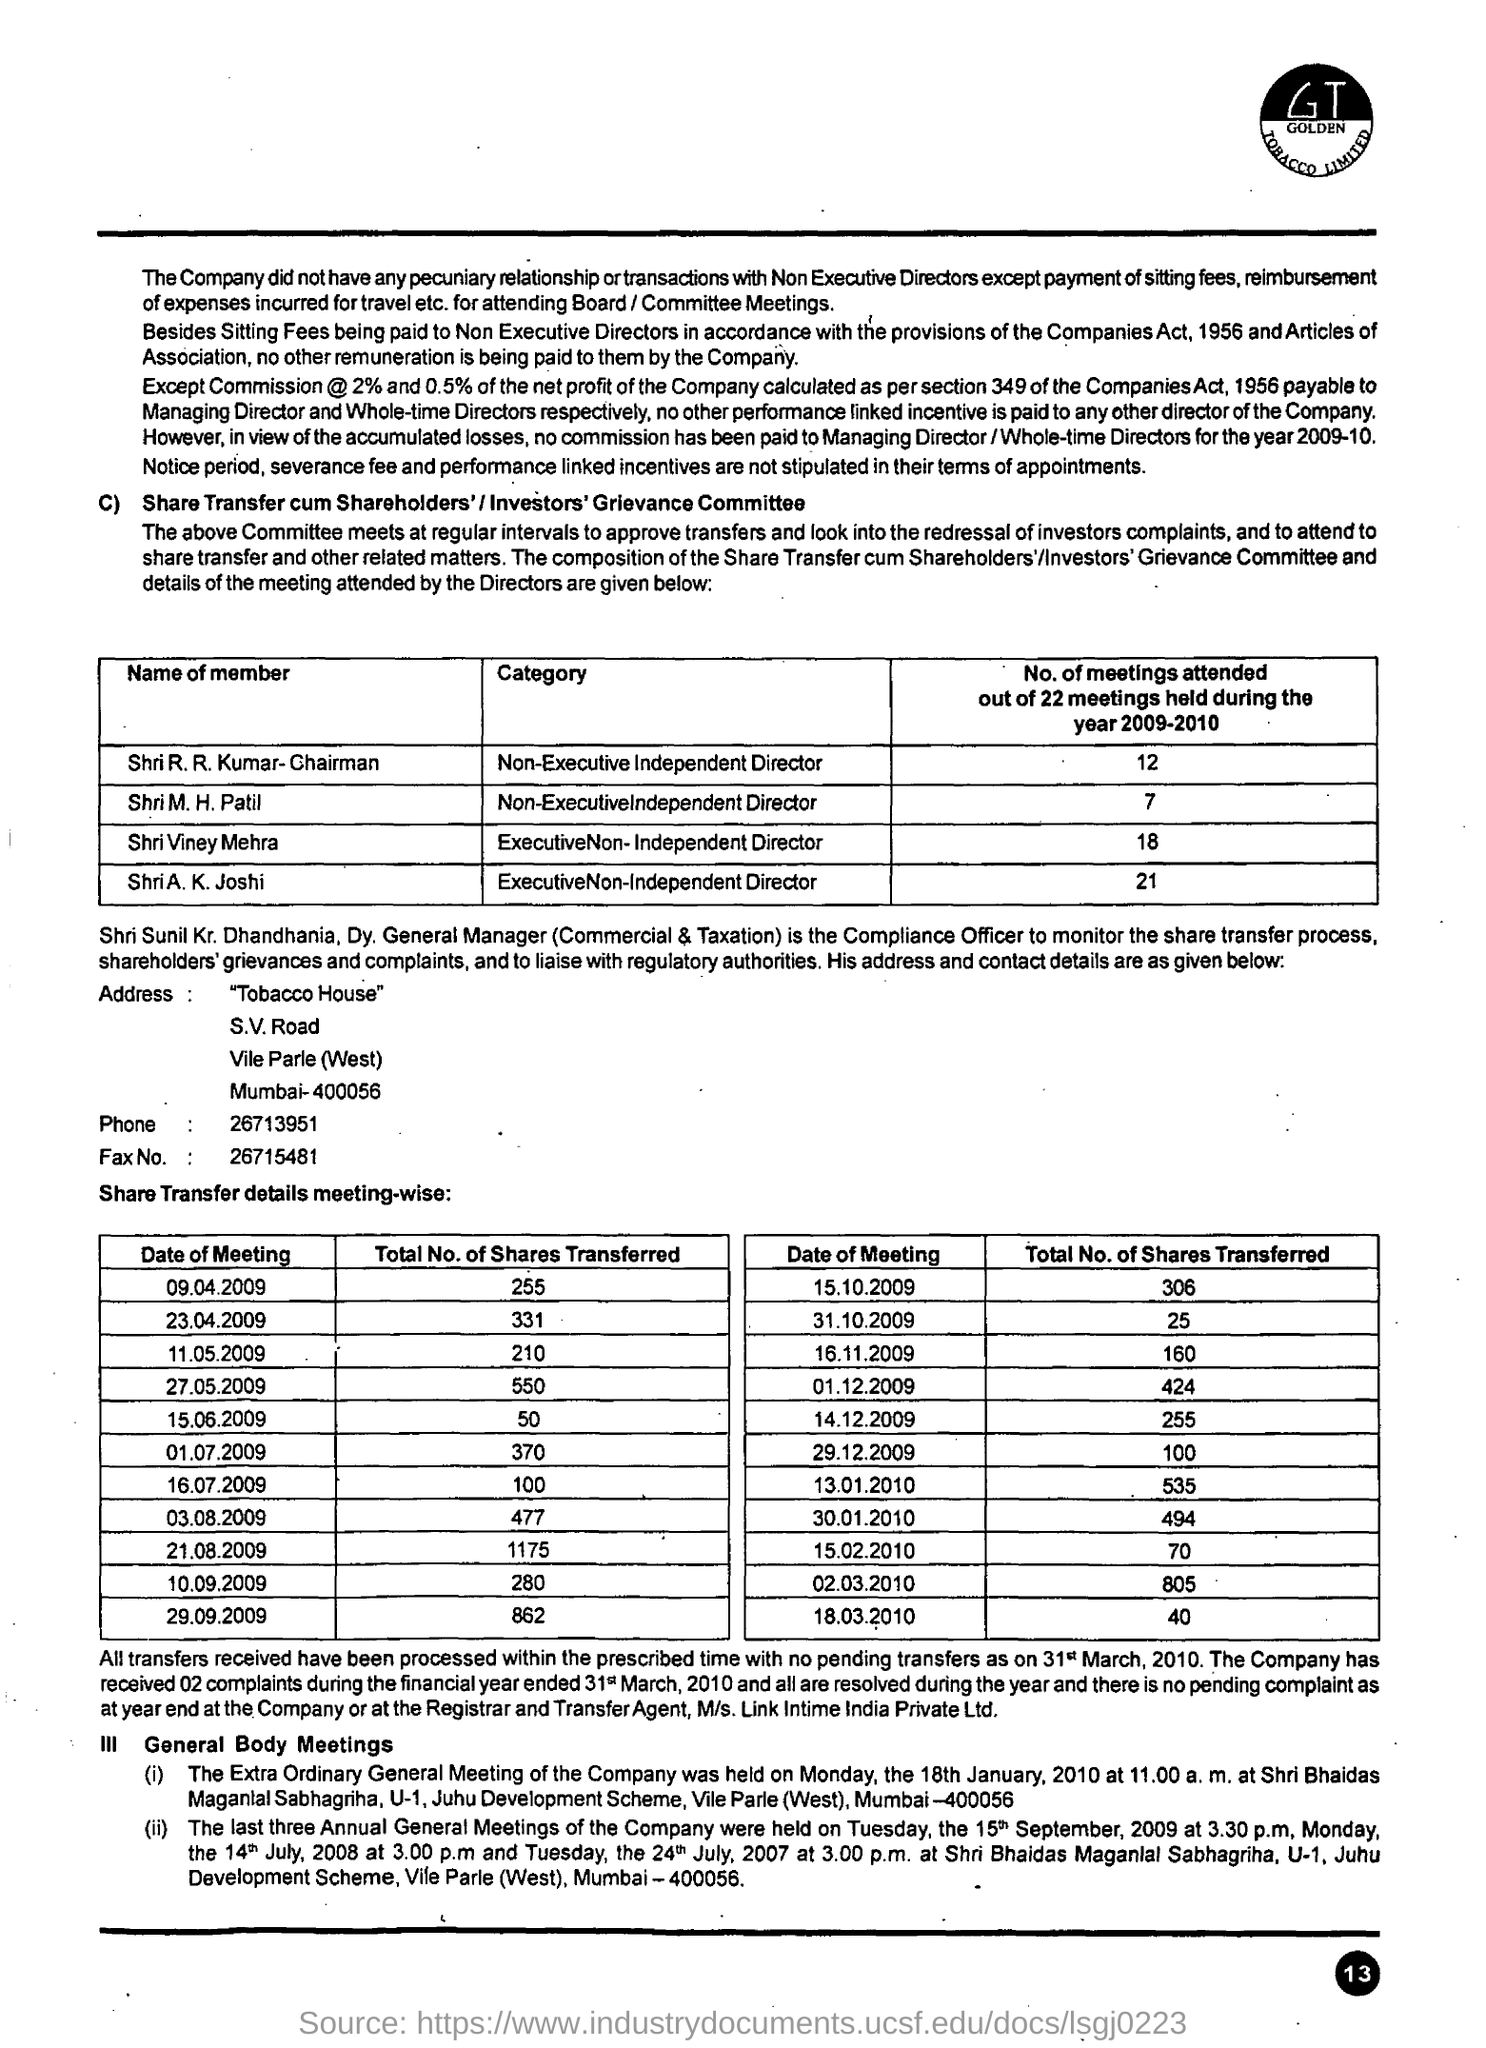No. meeting attended by Shri M. H. Patil in the year of 2009-2010?
Keep it short and to the point. 7. 